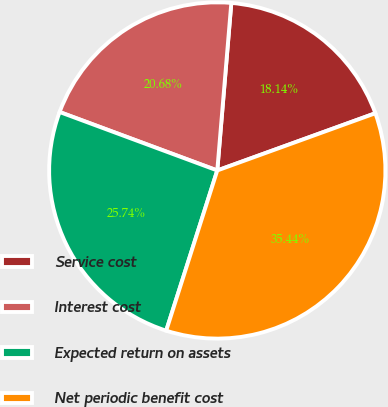Convert chart to OTSL. <chart><loc_0><loc_0><loc_500><loc_500><pie_chart><fcel>Service cost<fcel>Interest cost<fcel>Expected return on assets<fcel>Net periodic benefit cost<nl><fcel>18.14%<fcel>20.68%<fcel>25.74%<fcel>35.44%<nl></chart> 